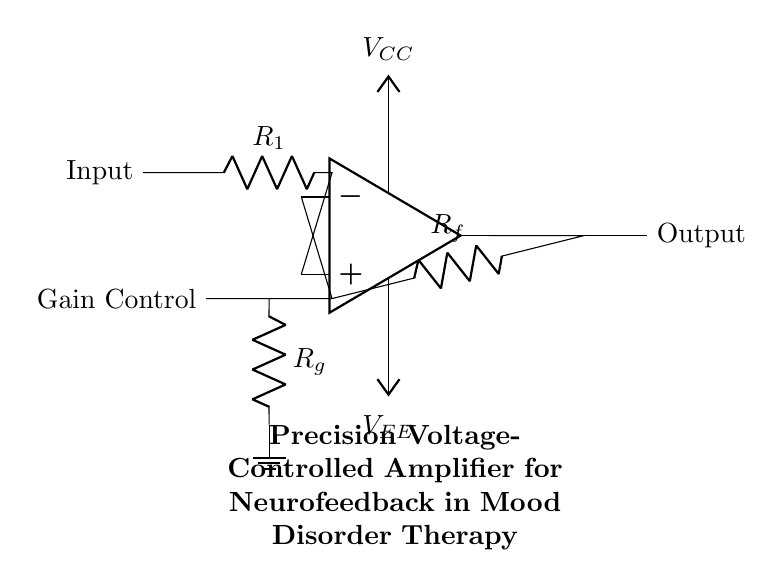What type of amplifier is shown in the diagram? The circuit is a precision voltage-controlled amplifier, which is specified in the title and supports mood disorder therapy through neurofeedback systems.
Answer: precision voltage-controlled amplifier What is the role of R1 in this circuit? R1 is the input resistor that is connected to the non-inverting input of the operational amplifier, affecting the input impedance and gain.
Answer: input resistor What is the purpose of the feedback resistor Rf? Rf determines the gain of the amplifier by creating a feedback loop; its value influences the output voltage in relation to the input voltage.
Answer: gain determination How does the gain control Rg affect the circuit? Rg controls the gain of the amplifier, allowing for adjustments to the sensitivity of the response, which is critical for neurofeedback applications.
Answer: gain adjustment What are the two voltage supplies connected to the operational amplifier? The operational amplifier is powered by a positive supply voltage (Vcc) and a negative supply voltage (Vee) which are essential for its operation.
Answer: Vcc and Vee What connects the output of the amplifier to external circuitry? The output of the amplifier is connected directly to an output terminal indicated in the circuit diagram, allowing for signal transmission to further systems.
Answer: output terminal What is indicated at the ground connection in the circuit? The ground connection is a reference point for the circuit, ensuring stability and providing a zero voltage level for the signals in the circuit.
Answer: ground reference 